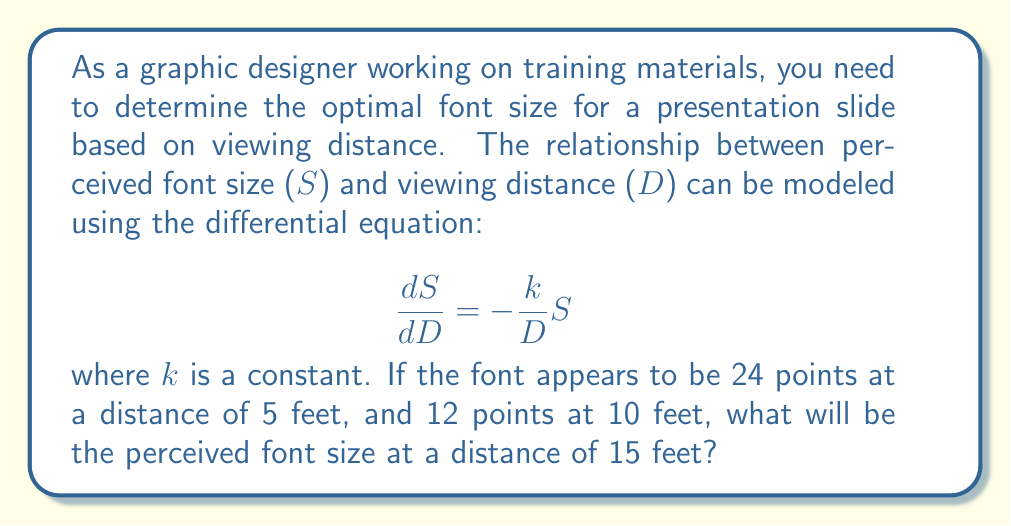Provide a solution to this math problem. To solve this problem, we'll follow these steps:

1) First, we need to solve the given differential equation. The equation is separable:

   $$\frac{dS}{S} = -\frac{k}{D}dD$$

2) Integrating both sides:

   $$\int\frac{dS}{S} = -k\int\frac{dD}{D}$$
   $$\ln|S| = -k\ln|D| + C$$

3) Simplifying:

   $$S = Ce^{-k\ln|D|} = C D^{-k}$$

   where C is a constant of integration.

4) Now we can use the given information to find k and C. Let's use the two known points:
   At D = 5, S = 24
   At D = 10, S = 12

5) Substituting these into our equation:

   $$24 = C(5)^{-k}$$
   $$12 = C(10)^{-k}$$

6) Dividing these equations:

   $$\frac{24}{12} = \frac{C(5)^{-k}}{C(10)^{-k}} = (\frac{10}{5})^k = 2^k$$

7) Solving for k:

   $$2 = 2^k$$
   $$k = 1$$

8) Now we can find C using either of the original equations. Let's use the first one:

   $$24 = C(5)^{-1}$$
   $$C = 24 * 5 = 120$$

9) So our final equation is:

   $$S = 120D^{-1}$$

10) To find the perceived font size at 15 feet, we simply substitute D = 15:

    $$S = 120(15)^{-1} = 8$$

Therefore, at a distance of 15 feet, the perceived font size will be 8 points.
Answer: 8 points 